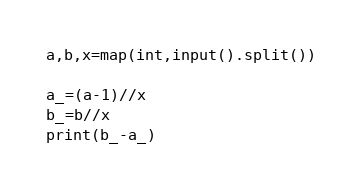Convert code to text. <code><loc_0><loc_0><loc_500><loc_500><_Python_>a,b,x=map(int,input().split())

a_=(a-1)//x
b_=b//x
print(b_-a_)</code> 